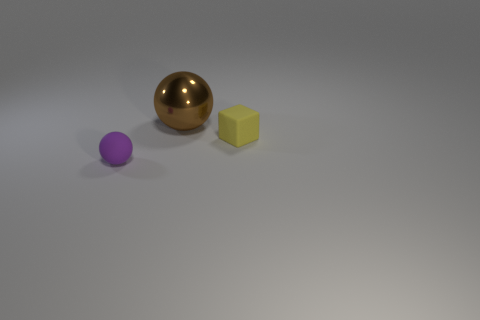What do you think the sizes of these objects might suggest about their weight? The sizes of the objects could imply a difference in their weights. The gold sphere appears to be the largest and, depending on the material, likely the heaviest. The cube is medium-sized and may have a moderate weight. The purple object is the smallest and would presumably be the lightest among the three. 